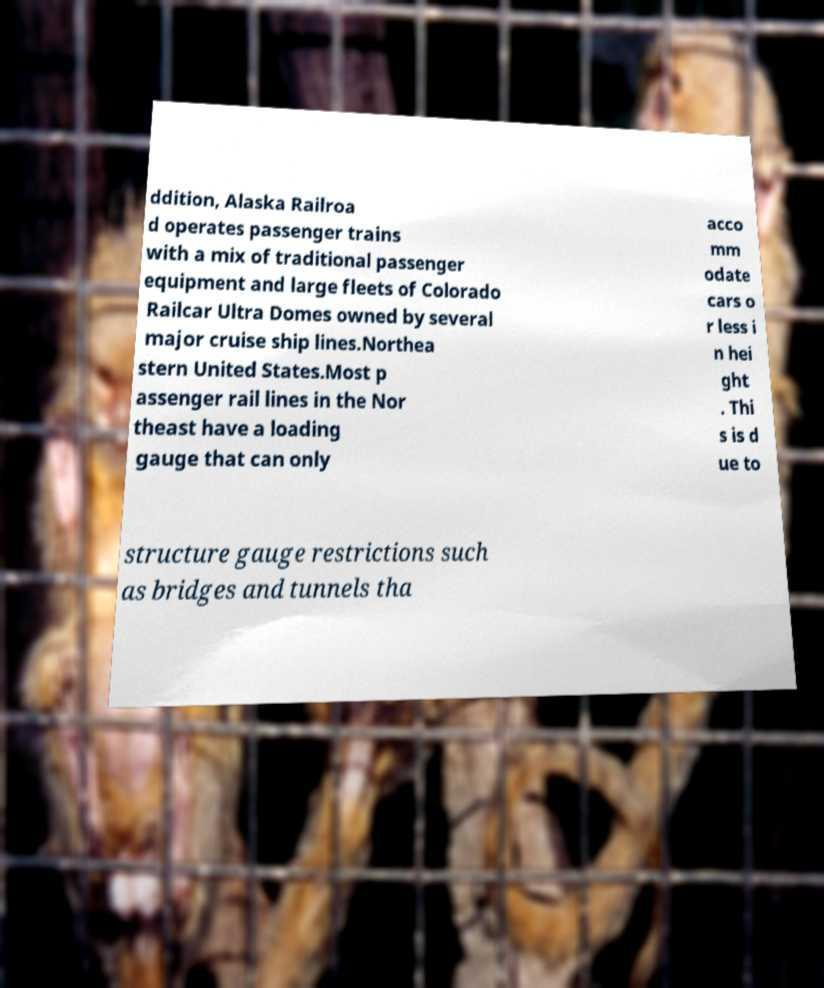For documentation purposes, I need the text within this image transcribed. Could you provide that? ddition, Alaska Railroa d operates passenger trains with a mix of traditional passenger equipment and large fleets of Colorado Railcar Ultra Domes owned by several major cruise ship lines.Northea stern United States.Most p assenger rail lines in the Nor theast have a loading gauge that can only acco mm odate cars o r less i n hei ght . Thi s is d ue to structure gauge restrictions such as bridges and tunnels tha 